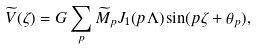Convert formula to latex. <formula><loc_0><loc_0><loc_500><loc_500>\widetilde { V } ( \zeta ) = G \sum _ { p } \widetilde { M } _ { p } J _ { 1 } ( p \Lambda ) \sin ( p \zeta + \theta _ { p } ) ,</formula> 